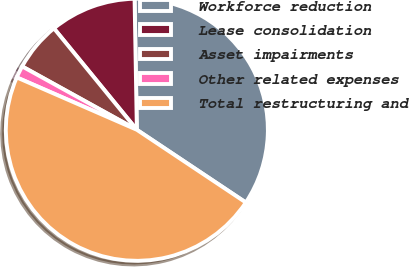<chart> <loc_0><loc_0><loc_500><loc_500><pie_chart><fcel>Workforce reduction<fcel>Lease consolidation<fcel>Asset impairments<fcel>Other related expenses<fcel>Total restructuring and<nl><fcel>34.64%<fcel>10.63%<fcel>6.06%<fcel>1.49%<fcel>47.18%<nl></chart> 